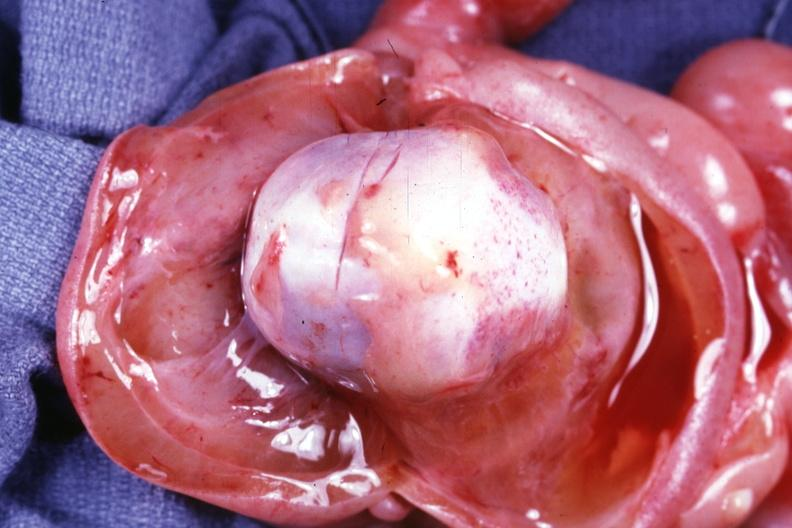s lymphangiomatosis present?
Answer the question using a single word or phrase. Yes 